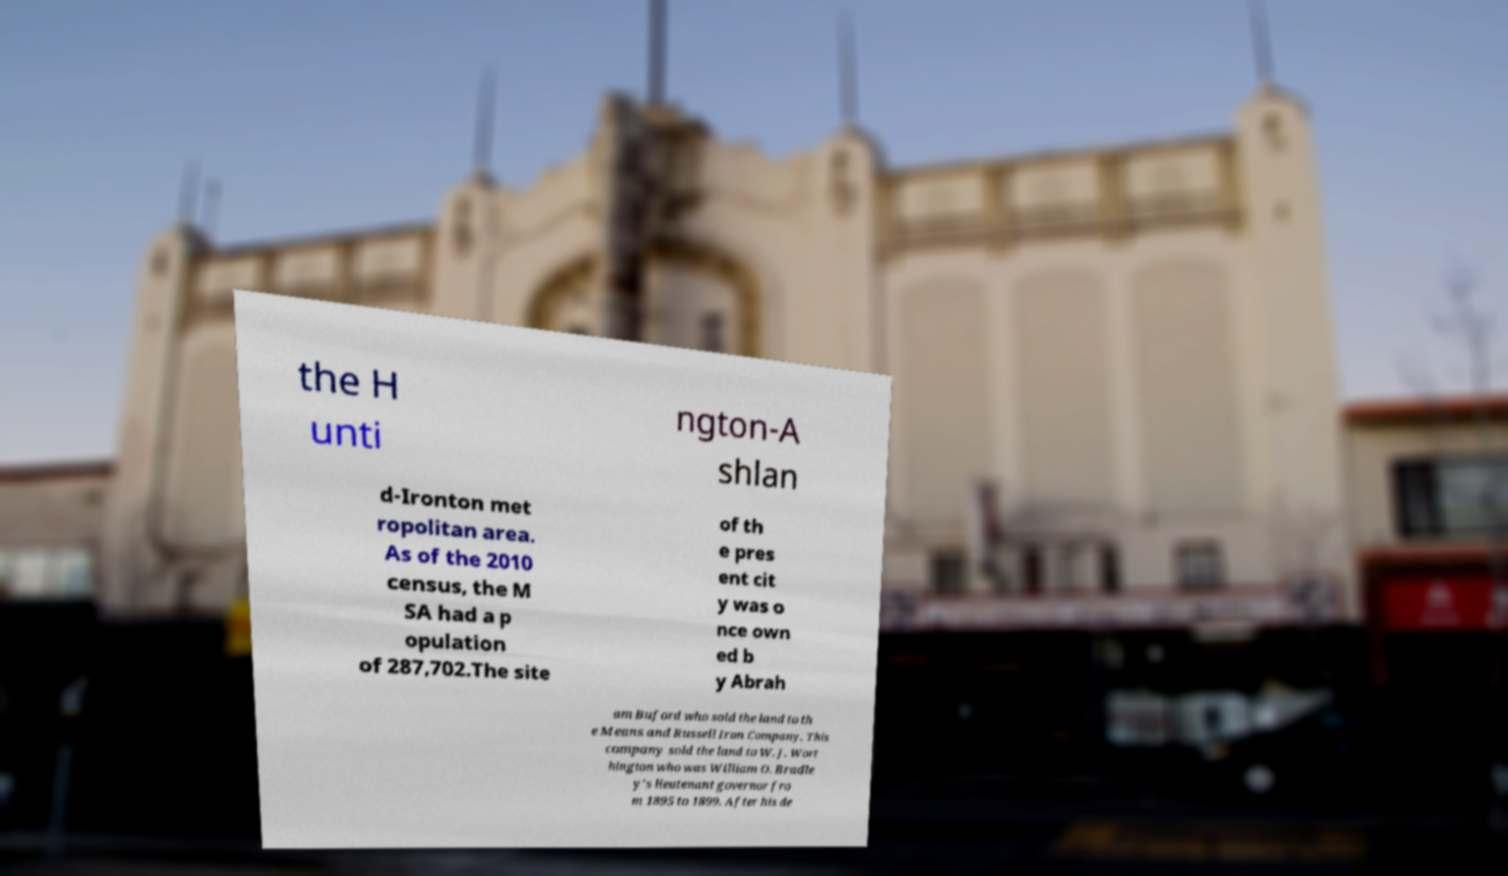What messages or text are displayed in this image? I need them in a readable, typed format. the H unti ngton-A shlan d-Ironton met ropolitan area. As of the 2010 census, the M SA had a p opulation of 287,702.The site of th e pres ent cit y was o nce own ed b y Abrah am Buford who sold the land to th e Means and Russell Iron Company. This company sold the land to W. J. Wort hington who was William O. Bradle y's lieutenant governor fro m 1895 to 1899. After his de 